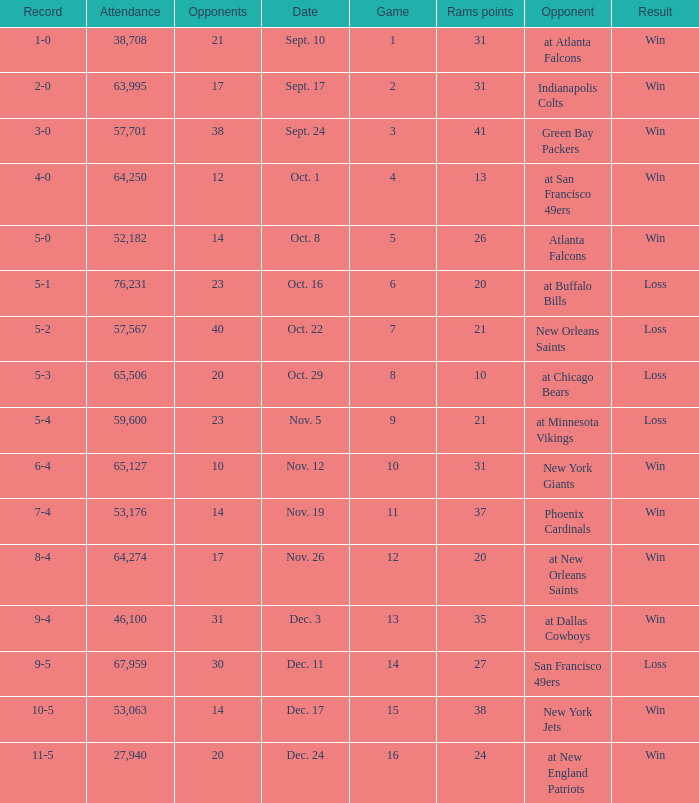What was the attendance where the record was 8-4? 64274.0. 